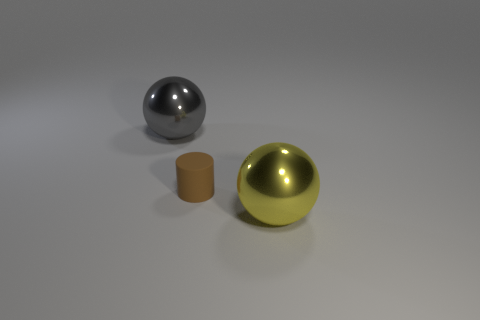There is a metallic sphere that is right of the big gray sphere; are there any balls behind it?
Your response must be concise. Yes. What number of other spheres are made of the same material as the large gray sphere?
Offer a terse response. 1. Are any yellow matte cylinders visible?
Make the answer very short. No. How many cylinders are the same color as the rubber thing?
Your answer should be very brief. 0. Do the brown cylinder and the ball that is on the right side of the gray metal thing have the same material?
Ensure brevity in your answer.  No. Are there more balls on the left side of the big yellow object than yellow rubber cylinders?
Give a very brief answer. Yes. Are there any other things that have the same size as the rubber thing?
Offer a very short reply. No. Is the color of the rubber object the same as the big thing that is in front of the gray sphere?
Give a very brief answer. No. Is the number of small brown rubber cylinders in front of the tiny brown cylinder the same as the number of large shiny things that are in front of the big gray shiny thing?
Offer a very short reply. No. There is a tiny brown object that is right of the big gray shiny object; what material is it?
Ensure brevity in your answer.  Rubber. 